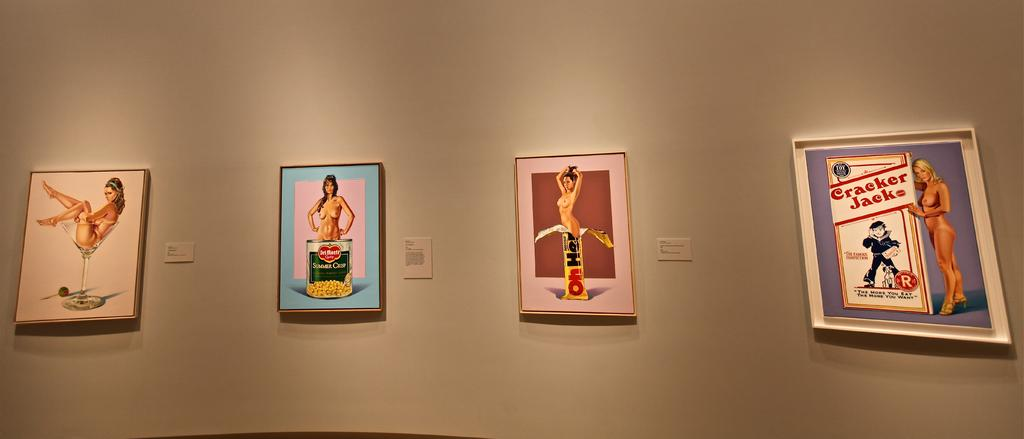<image>
Present a compact description of the photo's key features. An art gallery displays images of nude models next to classic food brands like Cracker Jack and Oh Henry. 